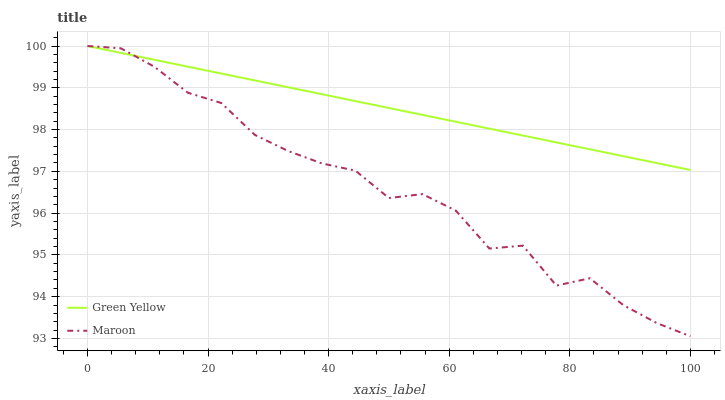Does Maroon have the maximum area under the curve?
Answer yes or no. No. Is Maroon the smoothest?
Answer yes or no. No. 